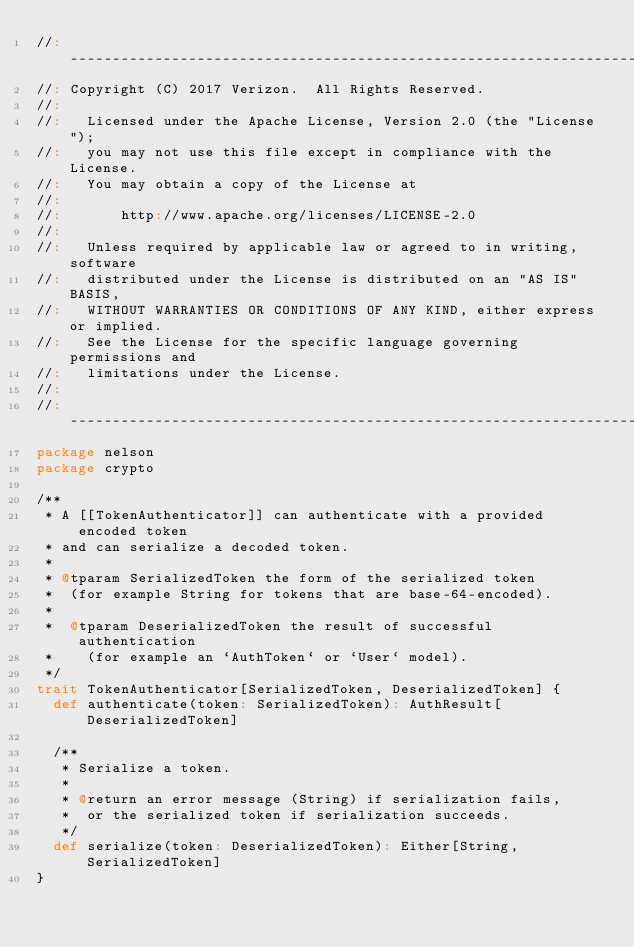<code> <loc_0><loc_0><loc_500><loc_500><_Scala_>//: ----------------------------------------------------------------------------
//: Copyright (C) 2017 Verizon.  All Rights Reserved.
//:
//:   Licensed under the Apache License, Version 2.0 (the "License");
//:   you may not use this file except in compliance with the License.
//:   You may obtain a copy of the License at
//:
//:       http://www.apache.org/licenses/LICENSE-2.0
//:
//:   Unless required by applicable law or agreed to in writing, software
//:   distributed under the License is distributed on an "AS IS" BASIS,
//:   WITHOUT WARRANTIES OR CONDITIONS OF ANY KIND, either express or implied.
//:   See the License for the specific language governing permissions and
//:   limitations under the License.
//:
//: ----------------------------------------------------------------------------
package nelson
package crypto

/**
 * A [[TokenAuthenticator]] can authenticate with a provided encoded token
 * and can serialize a decoded token.
 *
 * @tparam SerializedToken the form of the serialized token
 *  (for example String for tokens that are base-64-encoded).
 *
 *  @tparam DeserializedToken the result of successful authentication
 *    (for example an `AuthToken` or `User` model).
 */
trait TokenAuthenticator[SerializedToken, DeserializedToken] {
  def authenticate(token: SerializedToken): AuthResult[DeserializedToken]

  /**
   * Serialize a token.
   *
   * @return an error message (String) if serialization fails,
   *  or the serialized token if serialization succeeds.
   */
  def serialize(token: DeserializedToken): Either[String, SerializedToken]
}
</code> 